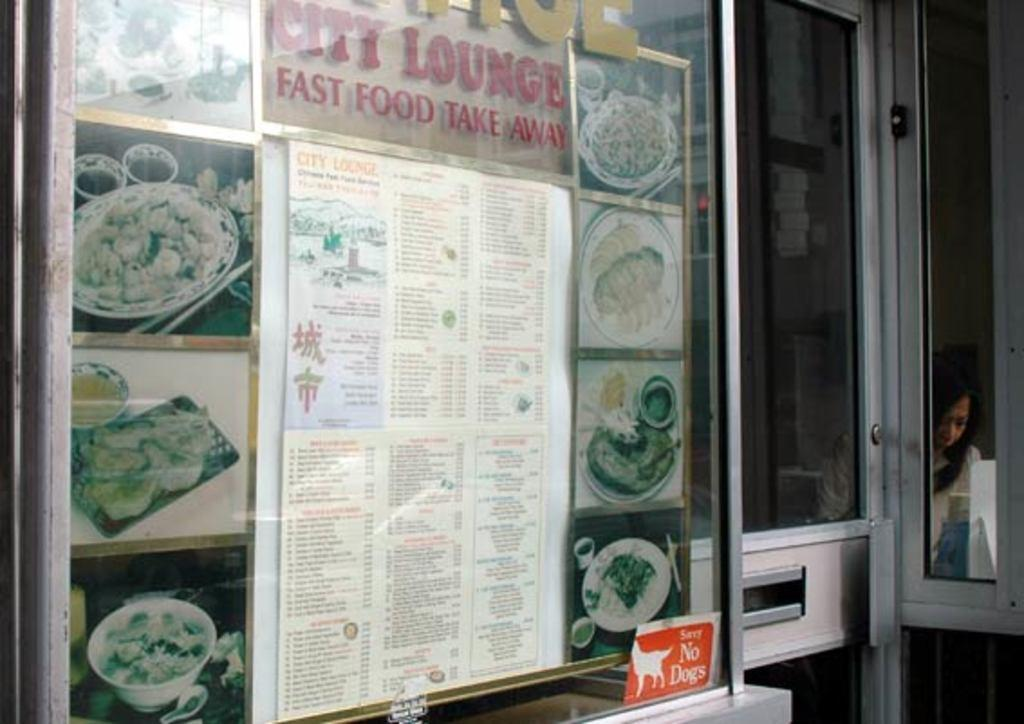<image>
Write a terse but informative summary of the picture. A menu for City Lounge is displayed and features the phrase "fast food take away." 